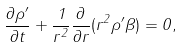Convert formula to latex. <formula><loc_0><loc_0><loc_500><loc_500>\frac { \partial \rho ^ { \prime } } { \partial t } + \frac { 1 } { r ^ { 2 } } \frac { \partial } { \partial r } ( r ^ { 2 } \rho ^ { \prime } \beta ) = 0 ,</formula> 